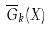Convert formula to latex. <formula><loc_0><loc_0><loc_500><loc_500>\overline { G } _ { k } ( X )</formula> 